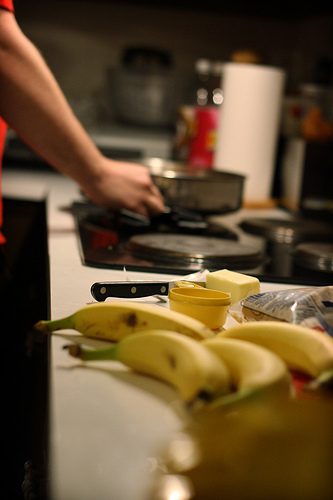Can you describe what the person is doing in the kitchen? The person appears to be focused on cooking or preparing something on the stove. They might be stirring or adjusting food in a pot. 